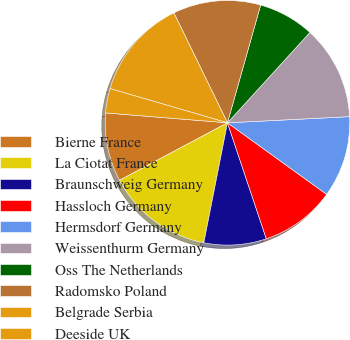<chart> <loc_0><loc_0><loc_500><loc_500><pie_chart><fcel>Bierne France<fcel>La Ciotat France<fcel>Braunschweig Germany<fcel>Hassloch Germany<fcel>Hermsdorf Germany<fcel>Weissenthurm Germany<fcel>Oss The Netherlands<fcel>Radomsko Poland<fcel>Belgrade Serbia<fcel>Deeside UK<nl><fcel>9.08%<fcel>14.11%<fcel>8.24%<fcel>9.91%<fcel>10.75%<fcel>12.43%<fcel>7.4%<fcel>11.59%<fcel>13.27%<fcel>3.22%<nl></chart> 